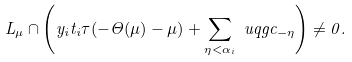Convert formula to latex. <formula><loc_0><loc_0><loc_500><loc_500>L _ { \mu } \cap \left ( y _ { i } t _ { i } \tau ( - \Theta ( \mu ) - \mu ) + \sum _ { \eta < \alpha _ { i } } \ u q g c _ { - \eta } \right ) \neq 0 .</formula> 